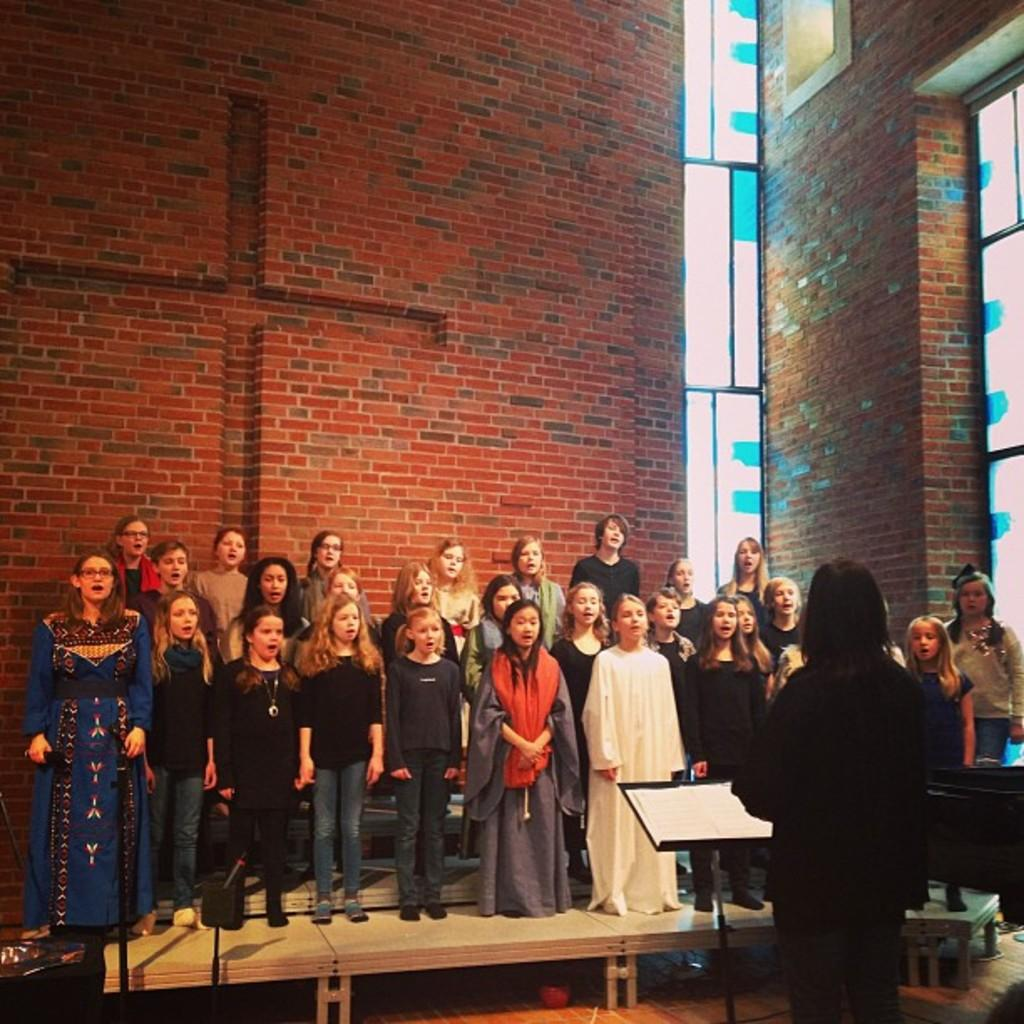Who is present in the image? There are girls and women in the image. What are they doing in the image? They are standing on a bench and singing. What can be seen behind the bench? There is a brick wall behind the bench. Is there any other significant feature in the image? Yes, there is a woman standing in front of a dias on the right side of the image. What type of pies are being served on the bench in the image? There are no pies present in the image; the girls and women are standing on the bench while singing. Is there any indication of flight in the image? There is no indication of flight in the image; the girls and women are standing on a bench, not flying. 